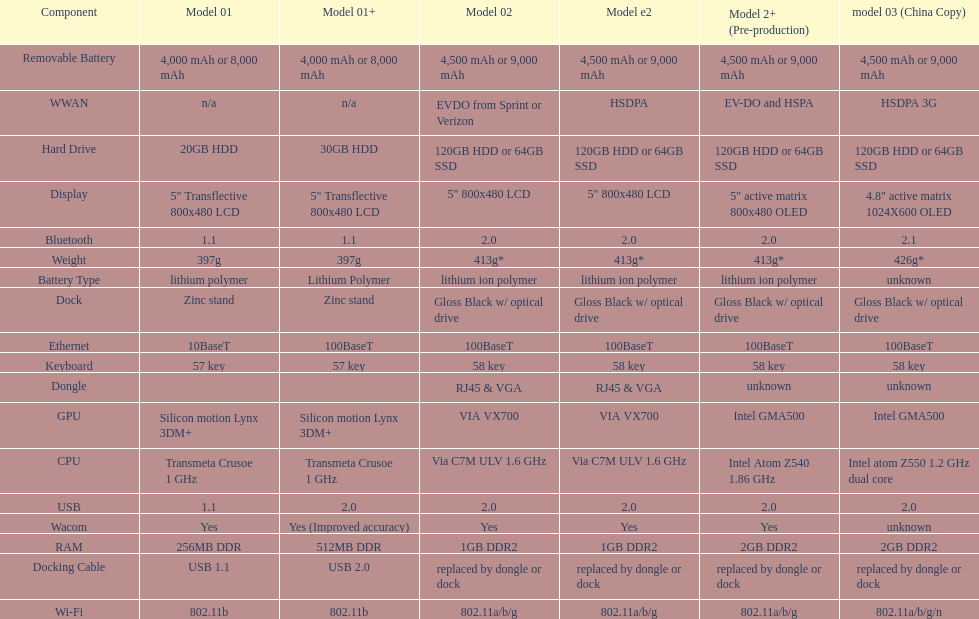What is the additional weight of the model 3 compared to model 1? 29g. 